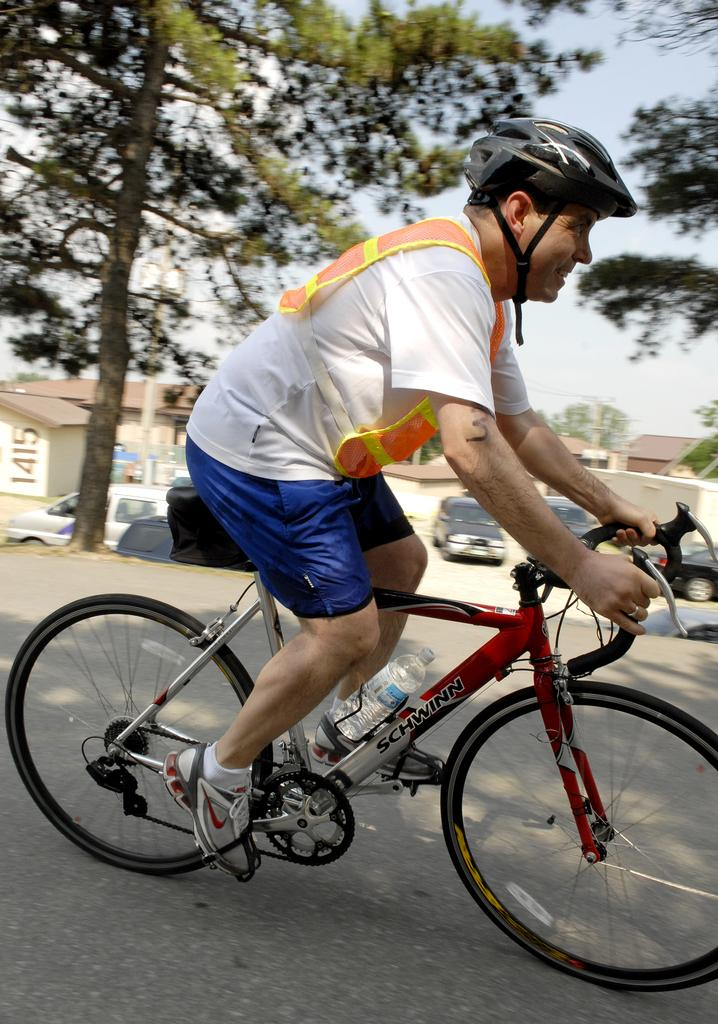What is the man in the image doing? The man is riding a bicycle in the image. What safety precaution is the man taking while riding the bicycle? The man is wearing a helmet. What can be seen in the background of the image? There is a tree in the background of the image. What else is visible in the image besides the man and the tree? There are vehicles visible in the image. What type of quill is the man using to write a letter while riding the bicycle? There is no quill or letter-writing activity present in the image; the man is simply riding a bicycle. 